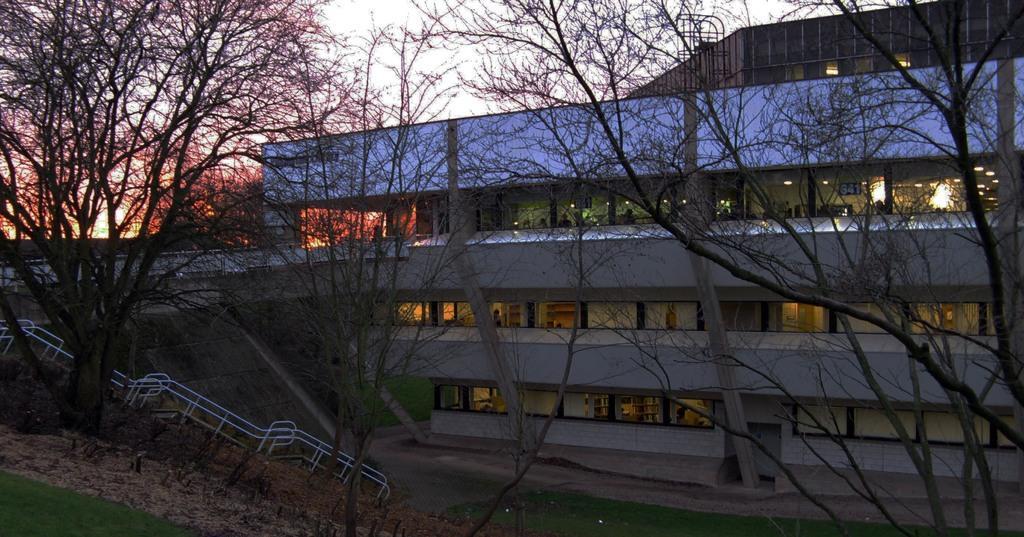Can you describe this image briefly? In the image in the center we can see trees,grass,lights,pillars,fence,building,wall and few people were standing. In the background we can see the sky and clouds. 